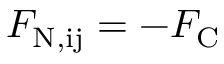<formula> <loc_0><loc_0><loc_500><loc_500>F _ { N , i j } = - F _ { C }</formula> 